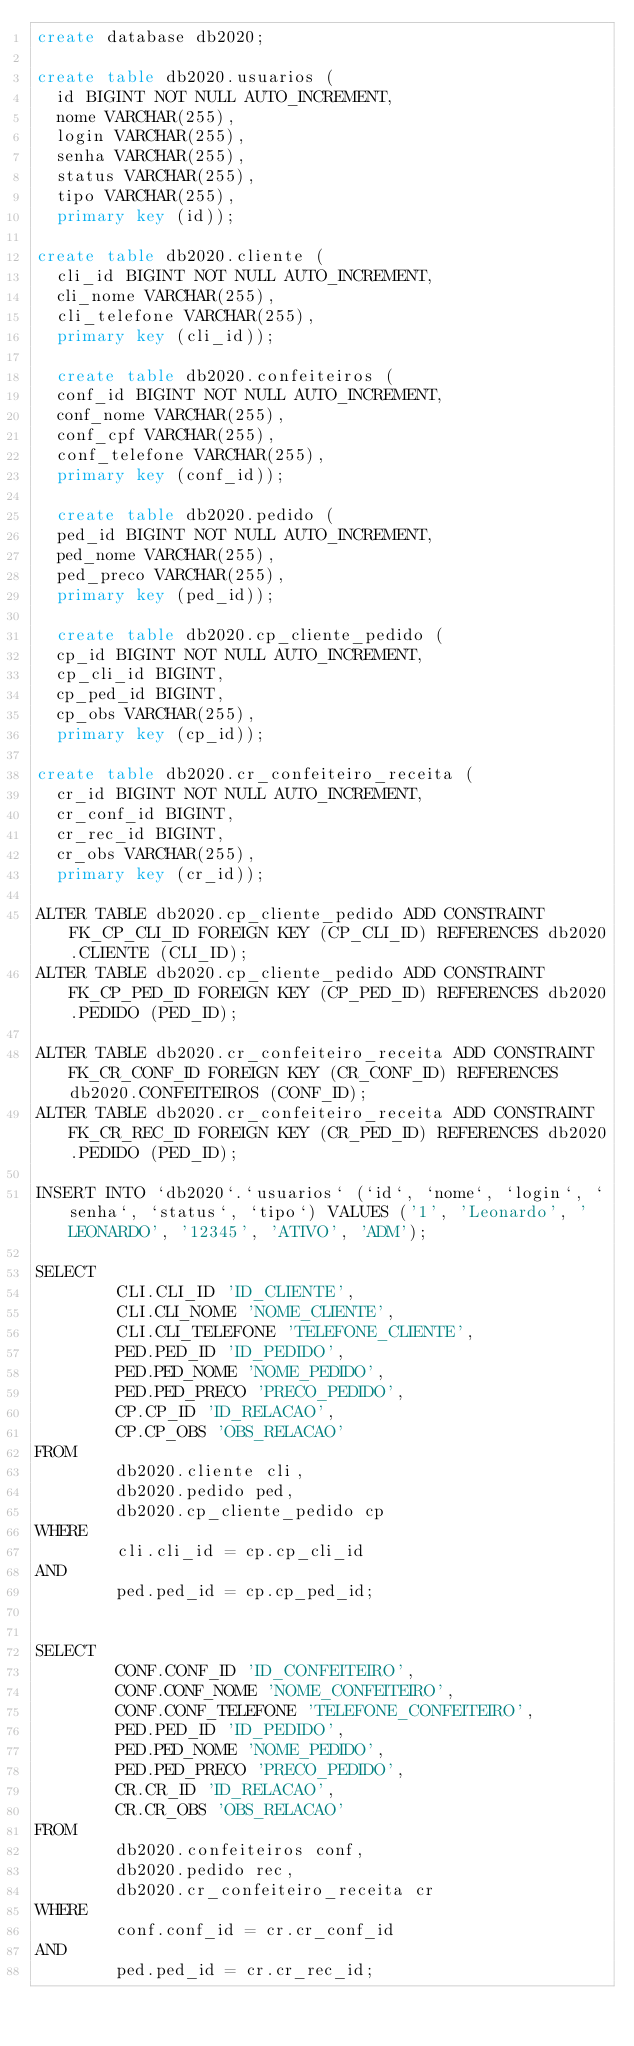Convert code to text. <code><loc_0><loc_0><loc_500><loc_500><_SQL_>create database db2020;
 
create table db2020.usuarios (
  id BIGINT NOT NULL AUTO_INCREMENT,
  nome VARCHAR(255),
  login VARCHAR(255),
  senha VARCHAR(255),
  status VARCHAR(255),
  tipo VARCHAR(255),
  primary key (id));

create table db2020.cliente (
  cli_id BIGINT NOT NULL AUTO_INCREMENT,
  cli_nome VARCHAR(255),
  cli_telefone VARCHAR(255),
  primary key (cli_id));
  
  create table db2020.confeiteiros (
  conf_id BIGINT NOT NULL AUTO_INCREMENT,
  conf_nome VARCHAR(255),
  conf_cpf VARCHAR(255),
  conf_telefone VARCHAR(255),
  primary key (conf_id));
  
  create table db2020.pedido (
  ped_id BIGINT NOT NULL AUTO_INCREMENT,
  ped_nome VARCHAR(255),
  ped_preco VARCHAR(255),
  primary key (ped_id));

  create table db2020.cp_cliente_pedido (
  cp_id BIGINT NOT NULL AUTO_INCREMENT,
  cp_cli_id BIGINT,
  cp_ped_id BIGINT,
  cp_obs VARCHAR(255),
  primary key (cp_id));

create table db2020.cr_confeiteiro_receita (
  cr_id BIGINT NOT NULL AUTO_INCREMENT,
  cr_conf_id BIGINT,
  cr_rec_id BIGINT,
  cr_obs VARCHAR(255),
  primary key (cr_id));
  
ALTER TABLE db2020.cp_cliente_pedido ADD CONSTRAINT FK_CP_CLI_ID FOREIGN KEY (CP_CLI_ID) REFERENCES db2020.CLIENTE (CLI_ID);
ALTER TABLE db2020.cp_cliente_pedido ADD CONSTRAINT FK_CP_PED_ID FOREIGN KEY (CP_PED_ID) REFERENCES db2020.PEDIDO (PED_ID);   

ALTER TABLE db2020.cr_confeiteiro_receita ADD CONSTRAINT FK_CR_CONF_ID FOREIGN KEY (CR_CONF_ID) REFERENCES db2020.CONFEITEIROS (CONF_ID);
ALTER TABLE db2020.cr_confeiteiro_receita ADD CONSTRAINT FK_CR_REC_ID FOREIGN KEY (CR_PED_ID) REFERENCES db2020.PEDIDO (PED_ID);  

INSERT INTO `db2020`.`usuarios` (`id`, `nome`, `login`, `senha`, `status`, `tipo`) VALUES ('1', 'Leonardo', 'LEONARDO', '12345', 'ATIVO', 'ADM');

SELECT     
        CLI.CLI_ID 'ID_CLIENTE', 
        CLI.CLI_NOME 'NOME_CLIENTE', 
        CLI.CLI_TELEFONE 'TELEFONE_CLIENTE',
        PED.PED_ID 'ID_PEDIDO',
        PED.PED_NOME 'NOME_PEDIDO',
        PED.PED_PRECO 'PRECO_PEDIDO', 
        CP.CP_ID 'ID_RELACAO', 
        CP.CP_OBS 'OBS_RELACAO'  
FROM 
        db2020.cliente cli, 
        db2020.pedido ped, 
        db2020.cp_cliente_pedido cp 
WHERE 
        cli.cli_id = cp.cp_cli_id 
AND 
        ped.ped_id = cp.cp_ped_id;


SELECT     
        CONF.CONF_ID 'ID_CONFEITEIRO', 
        CONF.CONF_NOME 'NOME_CONFEITEIRO', 
        CONF.CONF_TELEFONE 'TELEFONE_CONFEITEIRO',
        PED.PED_ID 'ID_PEDIDO',
        PED.PED_NOME 'NOME_PEDIDO',
        PED.PED_PRECO 'PRECO_PEDIDO', 
        CR.CR_ID 'ID_RELACAO', 
        CR.CR_OBS 'OBS_RELACAO'  
FROM 
        db2020.confeiteiros conf, 
        db2020.pedido rec, 
        db2020.cr_confeiteiro_receita cr 
WHERE 
        conf.conf_id = cr.cr_conf_id 
AND 
        ped.ped_id = cr.cr_rec_id;
</code> 